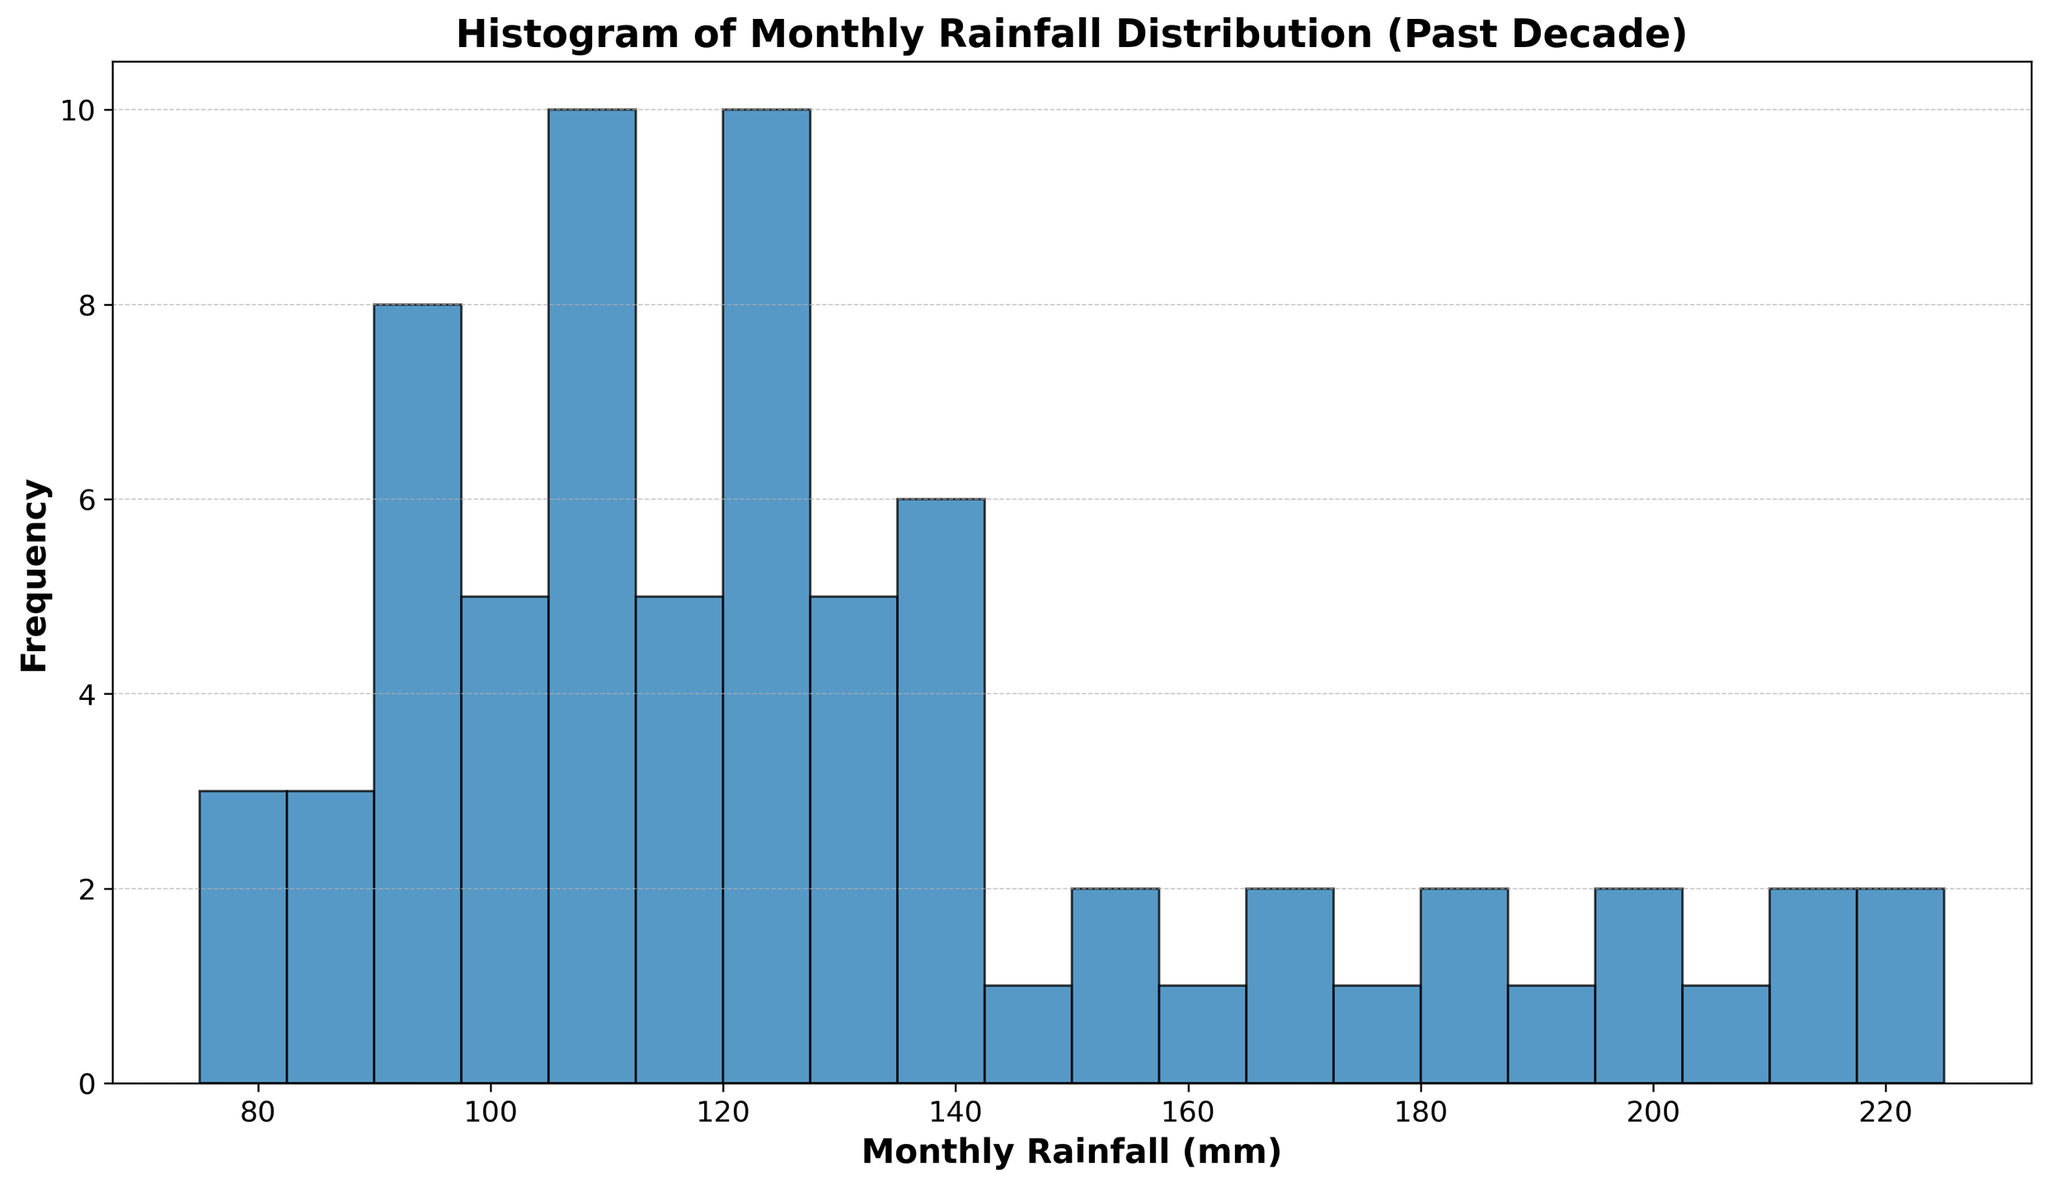What range of monthly rainfall has the highest frequency in the histogram? First, we observe the bins in the histogram. The highest bar visually represents the bin with the greatest frequency. Identify the range that this bin covers.
Answer: 210-220 mm How many bins are used to create the histogram? To determine this, count the number of bars (bins) in the histogram. Each bin corresponds to a range in the monthly rainfall distribution.
Answer: 20 Which interval has the lowest recorded frequency? Look for the shortest bar in the histogram. Identify the range on the x-axis that corresponds to this bin. This indicates the interval with the lowest frequency.
Answer: 220-230 mm Compare the frequency of monthly rainfall between 100-110 mm and 200-210 mm. Which is higher? Locate the bins for 100-110 mm and 200-210 mm on the histogram. Compare the heights of the bars for these two bins. The taller bar indicates the interval with the higher frequency.
Answer: 200-210 mm What is the mode of monthly rainfall recorded in this histogram? The mode is the value that appears most frequently in the data set. In a histogram, it's represented by the highest bar. Identify the range that this bar covers to determine the mode.
Answer: 210-220 mm Estimate the average monthly rainfall based on the histogram. To estimate the average, we can assess the center of the distribution. Identifying the balance point of the histogram visually should give an approximate mean value. Alternatively, look for a symmetric midpoint.
Answer: 165 mm (approx.) How many bins have a frequency of more than 10 occurrences? Count the bars in the histogram where the height exceeds the 10-occurrence mark on the y-axis.
Answer: 3 What is the total frequency of monthly rainfall between 150-200 mm? Identify the bins covering the range 150-200 mm. Sum their corresponding frequencies (heights of the bars). Estimate the counts or use the bar heights directly to get the summation.
Answer: 74 How does the frequency distribution of monthly rainfall below 150 mm compare to above 150 mm? Separate the histogram into two parts: below 150 mm and above. Observe and compare the heights of the bars in each section to determine which part has a higher overall frequency or seems denser.
Answer: Below 150 mm is less dense What visual elements help to distinguish different frequency levels in the histogram? Identify and describe visual cues such as the grid lines, bar heights, and different intervals' representations that help in understanding and differentiating frequency levels.
Answer: Grid lines, bar heights, edge color 